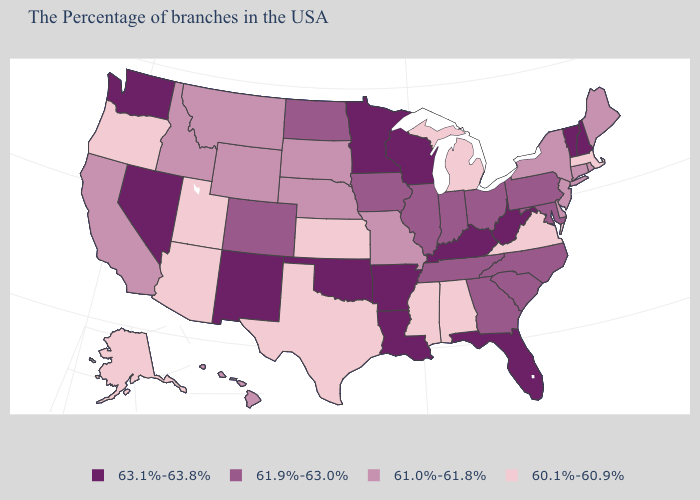Which states have the highest value in the USA?
Quick response, please. New Hampshire, Vermont, West Virginia, Florida, Kentucky, Wisconsin, Louisiana, Arkansas, Minnesota, Oklahoma, New Mexico, Nevada, Washington. Name the states that have a value in the range 61.9%-63.0%?
Keep it brief. Maryland, Pennsylvania, North Carolina, South Carolina, Ohio, Georgia, Indiana, Tennessee, Illinois, Iowa, North Dakota, Colorado. Among the states that border Nevada , which have the highest value?
Concise answer only. Idaho, California. What is the value of Iowa?
Be succinct. 61.9%-63.0%. What is the value of California?
Concise answer only. 61.0%-61.8%. What is the value of Rhode Island?
Give a very brief answer. 61.0%-61.8%. Among the states that border Vermont , does Massachusetts have the lowest value?
Be succinct. Yes. What is the value of Michigan?
Short answer required. 60.1%-60.9%. Among the states that border Utah , which have the highest value?
Be succinct. New Mexico, Nevada. Which states hav the highest value in the South?
Answer briefly. West Virginia, Florida, Kentucky, Louisiana, Arkansas, Oklahoma. Name the states that have a value in the range 61.0%-61.8%?
Short answer required. Maine, Rhode Island, Connecticut, New York, New Jersey, Delaware, Missouri, Nebraska, South Dakota, Wyoming, Montana, Idaho, California, Hawaii. What is the value of Georgia?
Write a very short answer. 61.9%-63.0%. Name the states that have a value in the range 61.9%-63.0%?
Give a very brief answer. Maryland, Pennsylvania, North Carolina, South Carolina, Ohio, Georgia, Indiana, Tennessee, Illinois, Iowa, North Dakota, Colorado. What is the highest value in states that border Idaho?
Answer briefly. 63.1%-63.8%. Which states have the highest value in the USA?
Keep it brief. New Hampshire, Vermont, West Virginia, Florida, Kentucky, Wisconsin, Louisiana, Arkansas, Minnesota, Oklahoma, New Mexico, Nevada, Washington. 